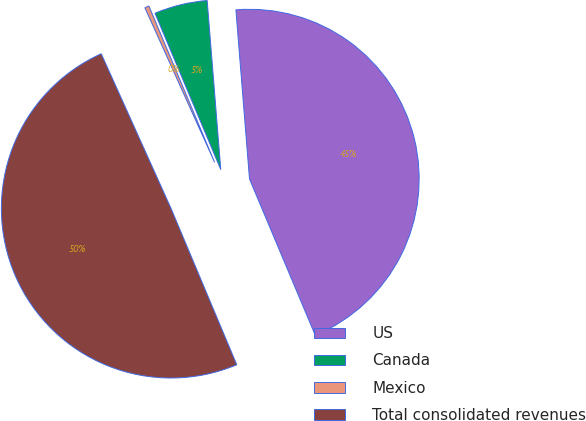Convert chart to OTSL. <chart><loc_0><loc_0><loc_500><loc_500><pie_chart><fcel>US<fcel>Canada<fcel>Mexico<fcel>Total consolidated revenues<nl><fcel>44.94%<fcel>5.06%<fcel>0.41%<fcel>49.59%<nl></chart> 